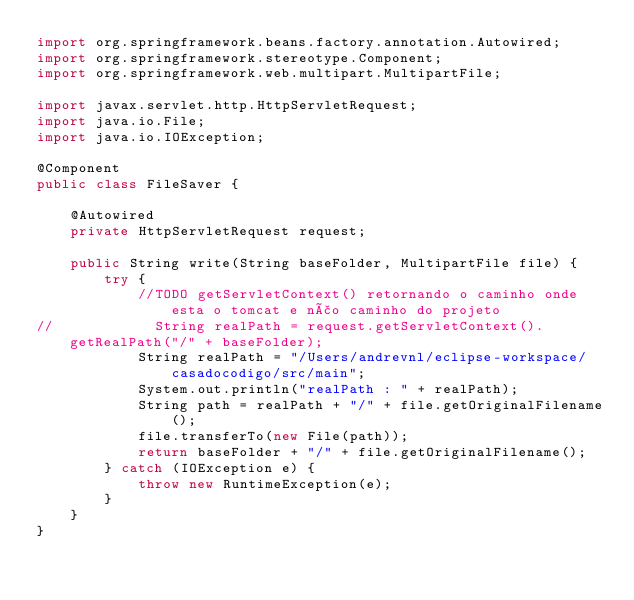<code> <loc_0><loc_0><loc_500><loc_500><_Java_>import org.springframework.beans.factory.annotation.Autowired;
import org.springframework.stereotype.Component;
import org.springframework.web.multipart.MultipartFile;

import javax.servlet.http.HttpServletRequest;
import java.io.File;
import java.io.IOException;

@Component
public class FileSaver {

    @Autowired
    private HttpServletRequest request;

    public String write(String baseFolder, MultipartFile file) {
        try {
            //TODO getServletContext() retornando o caminho onde esta o tomcat e não caminho do projeto
//            String realPath = request.getServletContext().getRealPath("/" + baseFolder);
            String realPath = "/Users/andrevnl/eclipse-workspace/casadocodigo/src/main";
            System.out.println("realPath : " + realPath);
            String path = realPath + "/" + file.getOriginalFilename();
            file.transferTo(new File(path));
            return baseFolder + "/" + file.getOriginalFilename();
        } catch (IOException e) {
            throw new RuntimeException(e);
        }
    }
}
</code> 